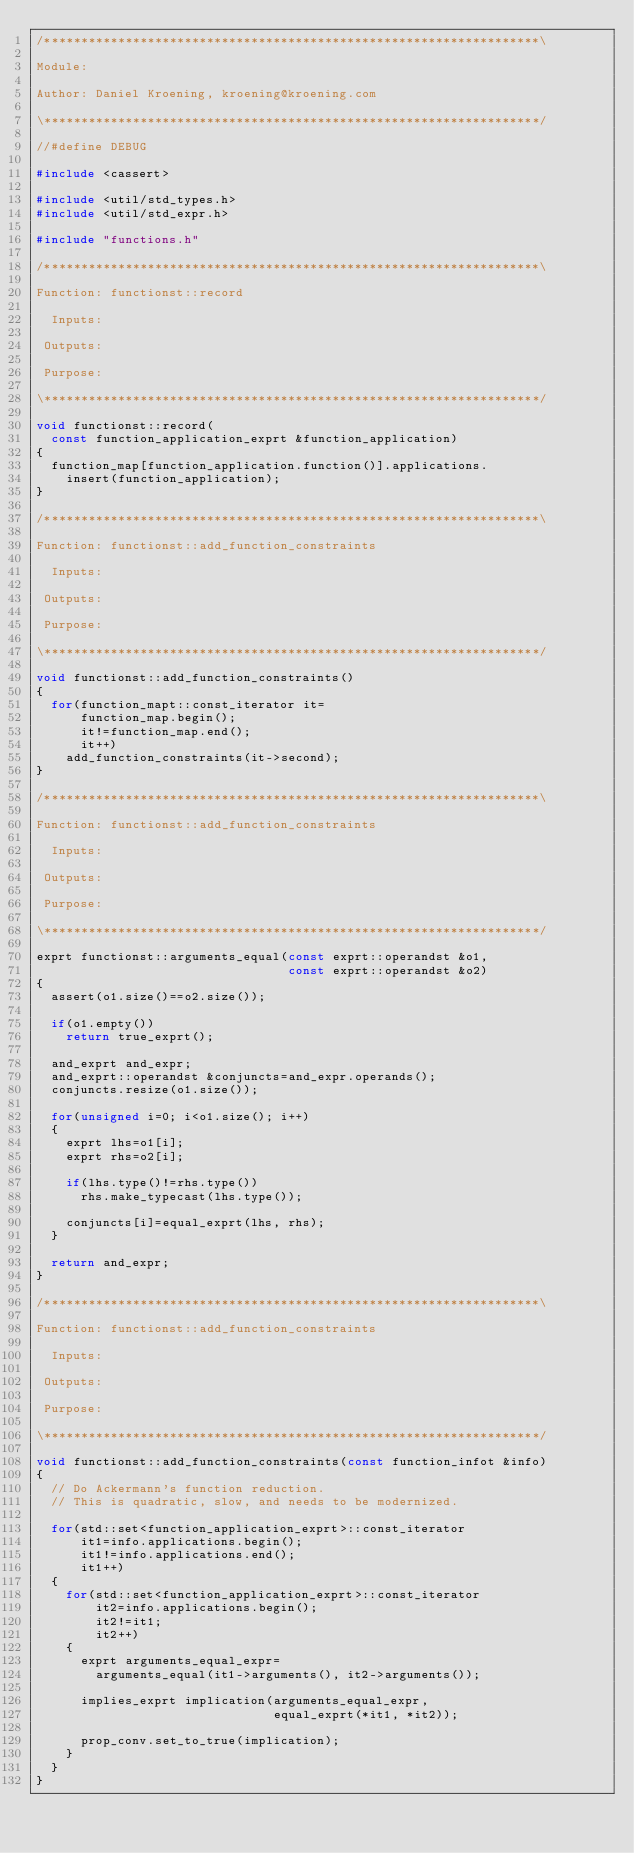Convert code to text. <code><loc_0><loc_0><loc_500><loc_500><_C++_>/*******************************************************************\

Module:

Author: Daniel Kroening, kroening@kroening.com

\*******************************************************************/

//#define DEBUG

#include <cassert>

#include <util/std_types.h>
#include <util/std_expr.h>

#include "functions.h"

/*******************************************************************\

Function: functionst::record

  Inputs:

 Outputs:

 Purpose:

\*******************************************************************/

void functionst::record(
  const function_application_exprt &function_application)
{
  function_map[function_application.function()].applications.
    insert(function_application);
}

/*******************************************************************\

Function: functionst::add_function_constraints

  Inputs:

 Outputs:

 Purpose:

\*******************************************************************/

void functionst::add_function_constraints()
{
  for(function_mapt::const_iterator it=
      function_map.begin();
      it!=function_map.end();
      it++)
    add_function_constraints(it->second);
}

/*******************************************************************\

Function: functionst::add_function_constraints

  Inputs:

 Outputs:

 Purpose:

\*******************************************************************/

exprt functionst::arguments_equal(const exprt::operandst &o1,
                                  const exprt::operandst &o2)
{
  assert(o1.size()==o2.size());
  
  if(o1.empty())
    return true_exprt();

  and_exprt and_expr;
  and_exprt::operandst &conjuncts=and_expr.operands();
  conjuncts.resize(o1.size());
  
  for(unsigned i=0; i<o1.size(); i++)
  {
    exprt lhs=o1[i];
    exprt rhs=o2[i];

    if(lhs.type()!=rhs.type())
      rhs.make_typecast(lhs.type());
      
    conjuncts[i]=equal_exprt(lhs, rhs);
  }

  return and_expr;
}

/*******************************************************************\

Function: functionst::add_function_constraints

  Inputs:

 Outputs:

 Purpose:

\*******************************************************************/

void functionst::add_function_constraints(const function_infot &info)
{
  // Do Ackermann's function reduction.
  // This is quadratic, slow, and needs to be modernized.

  for(std::set<function_application_exprt>::const_iterator
      it1=info.applications.begin();
      it1!=info.applications.end();
      it1++)
  {
    for(std::set<function_application_exprt>::const_iterator
        it2=info.applications.begin();
        it2!=it1;
        it2++)
    {
      exprt arguments_equal_expr=
        arguments_equal(it1->arguments(), it2->arguments());

      implies_exprt implication(arguments_equal_expr,
                                equal_exprt(*it1, *it2));
      
      prop_conv.set_to_true(implication);
    }
  }
}
</code> 